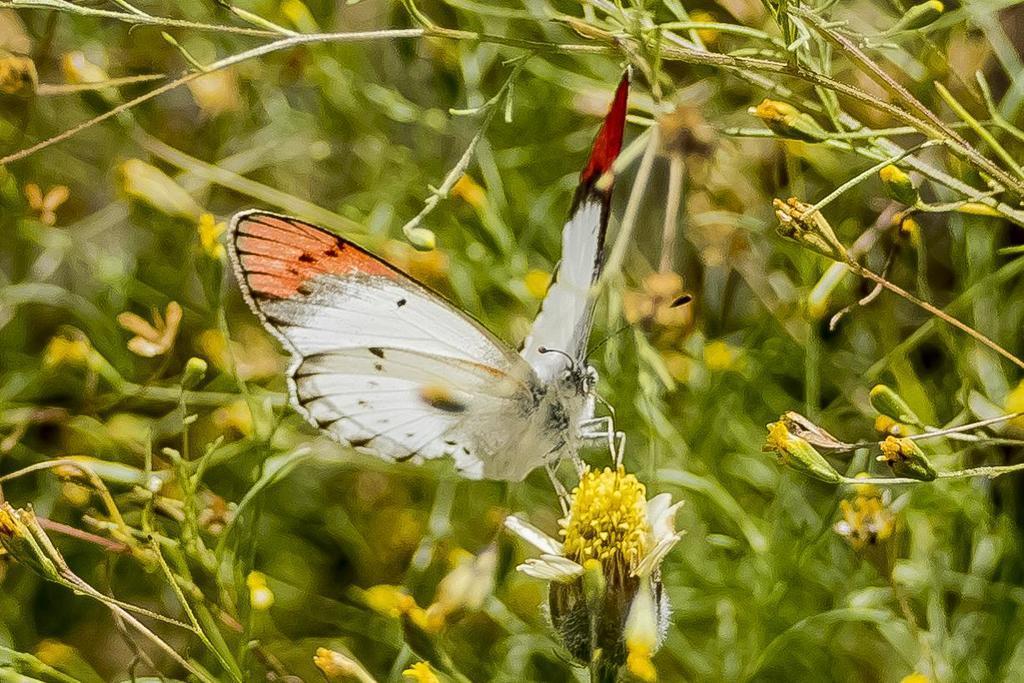Describe this image in one or two sentences. In this picture we can see a butterfly on the flower, in the background we can see few plants. 